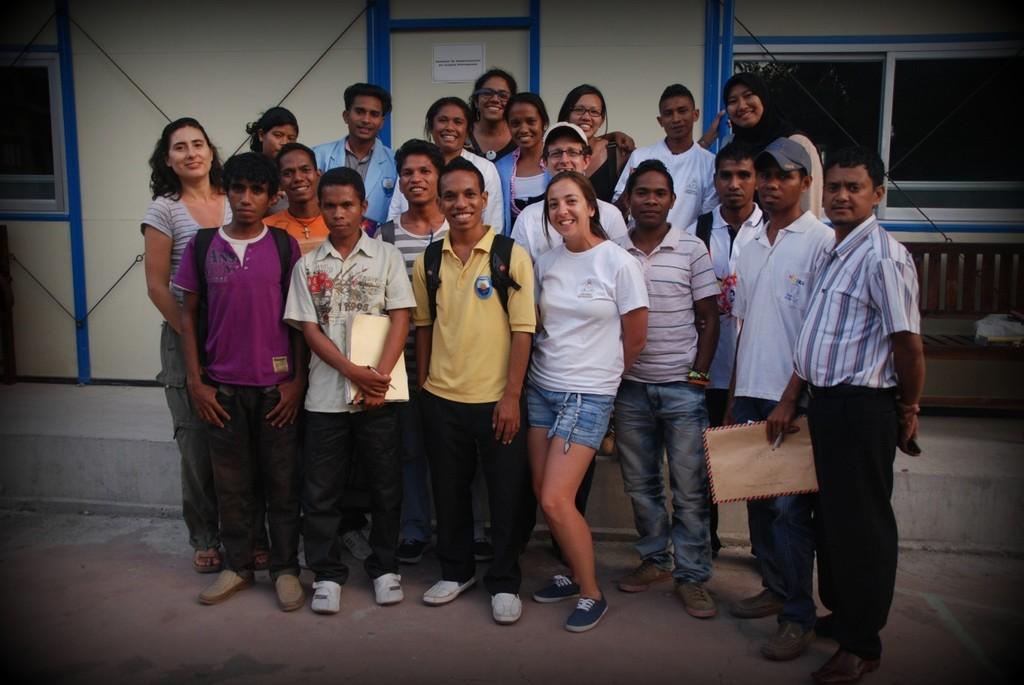In one or two sentences, can you explain what this image depicts? In this image there are a group of people standing and some of them are wearing bags, and some of them are holding some objects. And in the background there is a building, windows and some poster. At the bottom there is a walkway. 